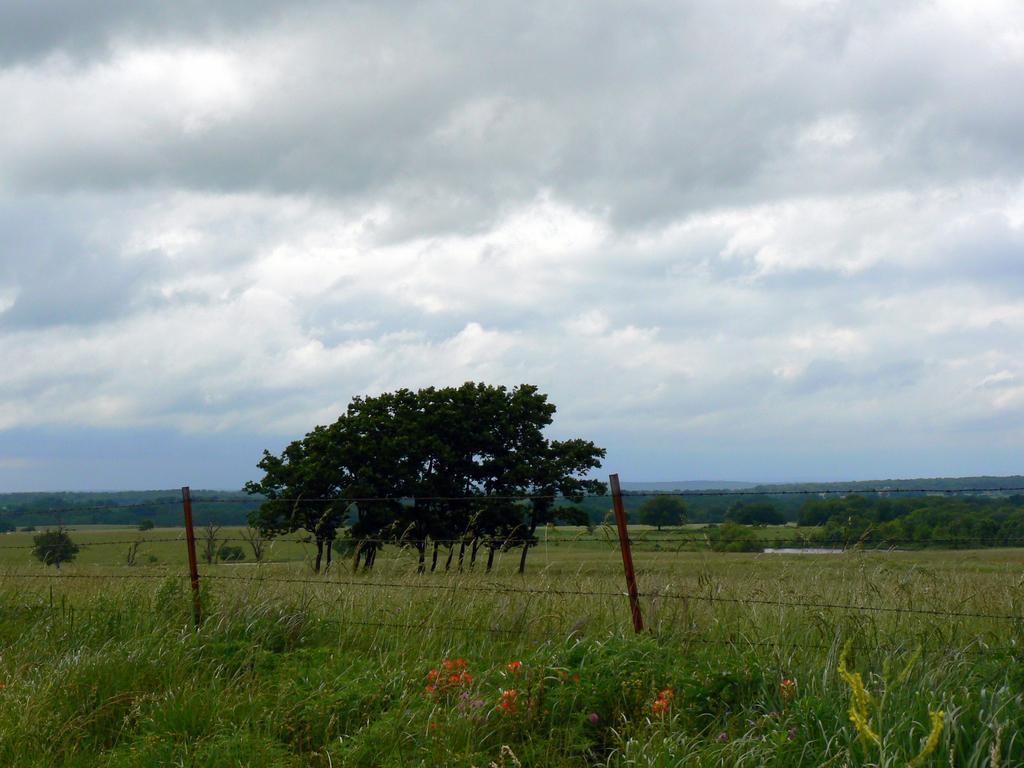Can you describe this image briefly? In this image there is grass on the ground. Behind it there is a fencing. Behind the fencing there are trees. In the background there are mountains. At the top there is the sky. 